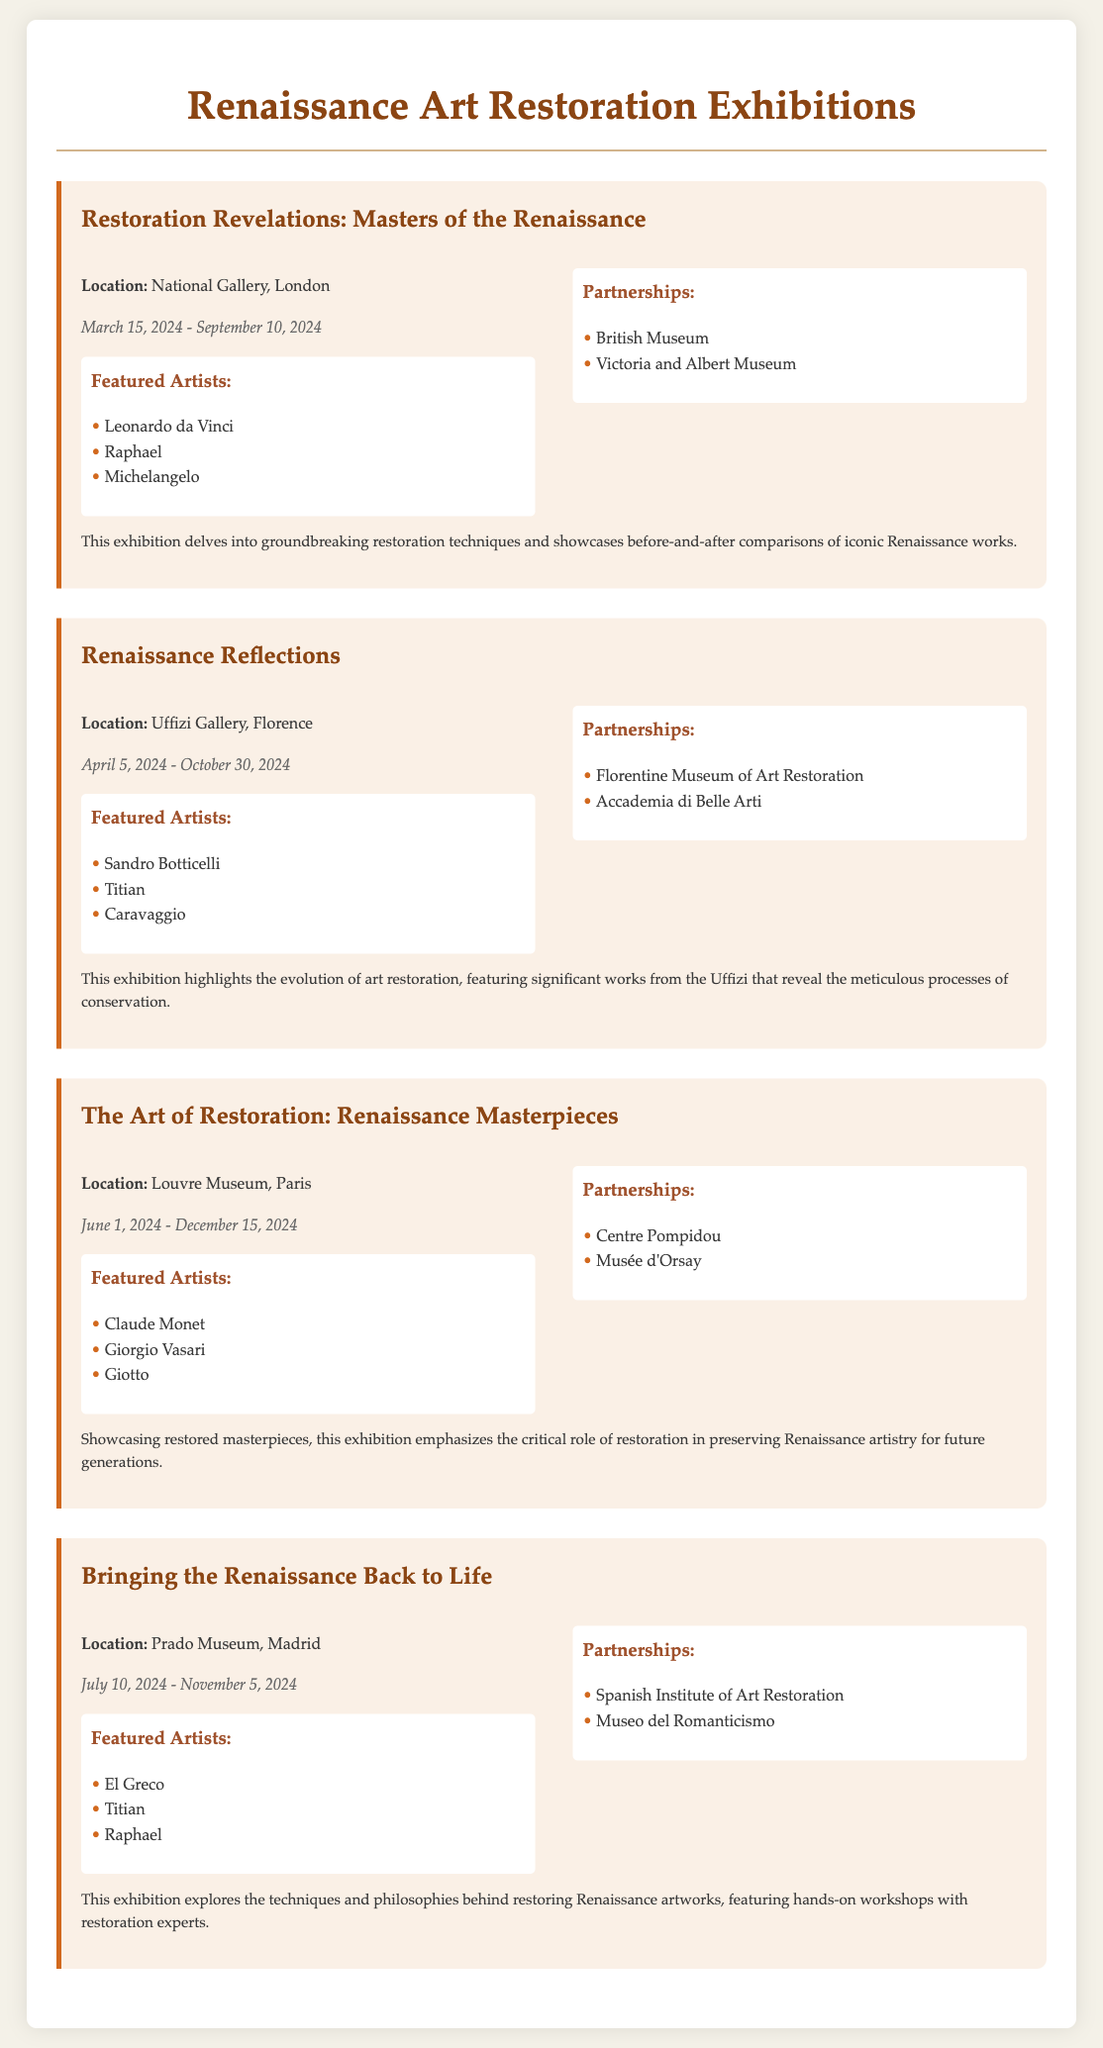what is the title of the first exhibition? The title of the first exhibition is highlighted in large text at the beginning of its section.
Answer: Restoration Revelations: Masters of the Renaissance which museum is hosting the "Renaissance Reflections" exhibition? The hosting museum's name is specified in the details section of the exhibition.
Answer: Uffizi Gallery what are the opening dates for "The Art of Restoration: Renaissance Masterpieces"? The exhibition's opening and closing dates are given in a designated section.
Answer: June 1, 2024 - December 15, 2024 how many featured artists are listed for the "Bringing the Renaissance Back to Life" exhibition? The number of featured artists is counted from the list provided in the exhibition's details.
Answer: 3 which artist is mentioned in both the "Restoration Revelations" and "Bringing the Renaissance Back to Life" exhibitions? The artist's name is found by cross-referencing the featured artists in both exhibition sections.
Answer: Raphael what partnership is associated with the "Renaissance Reflections" exhibition? Partnerships are listed under each exhibition, detailing the collaborating institutions.
Answer: Florentine Museum of Art Restoration which exhibitions take place in London? The location of the exhibitions is specified in their respective details.
Answer: Restoration Revelations: Masters of the Renaissance how many exhibitions are listed in total? The total number of exhibitions can be determined by counting the number of exhibition sections in the document.
Answer: 4 